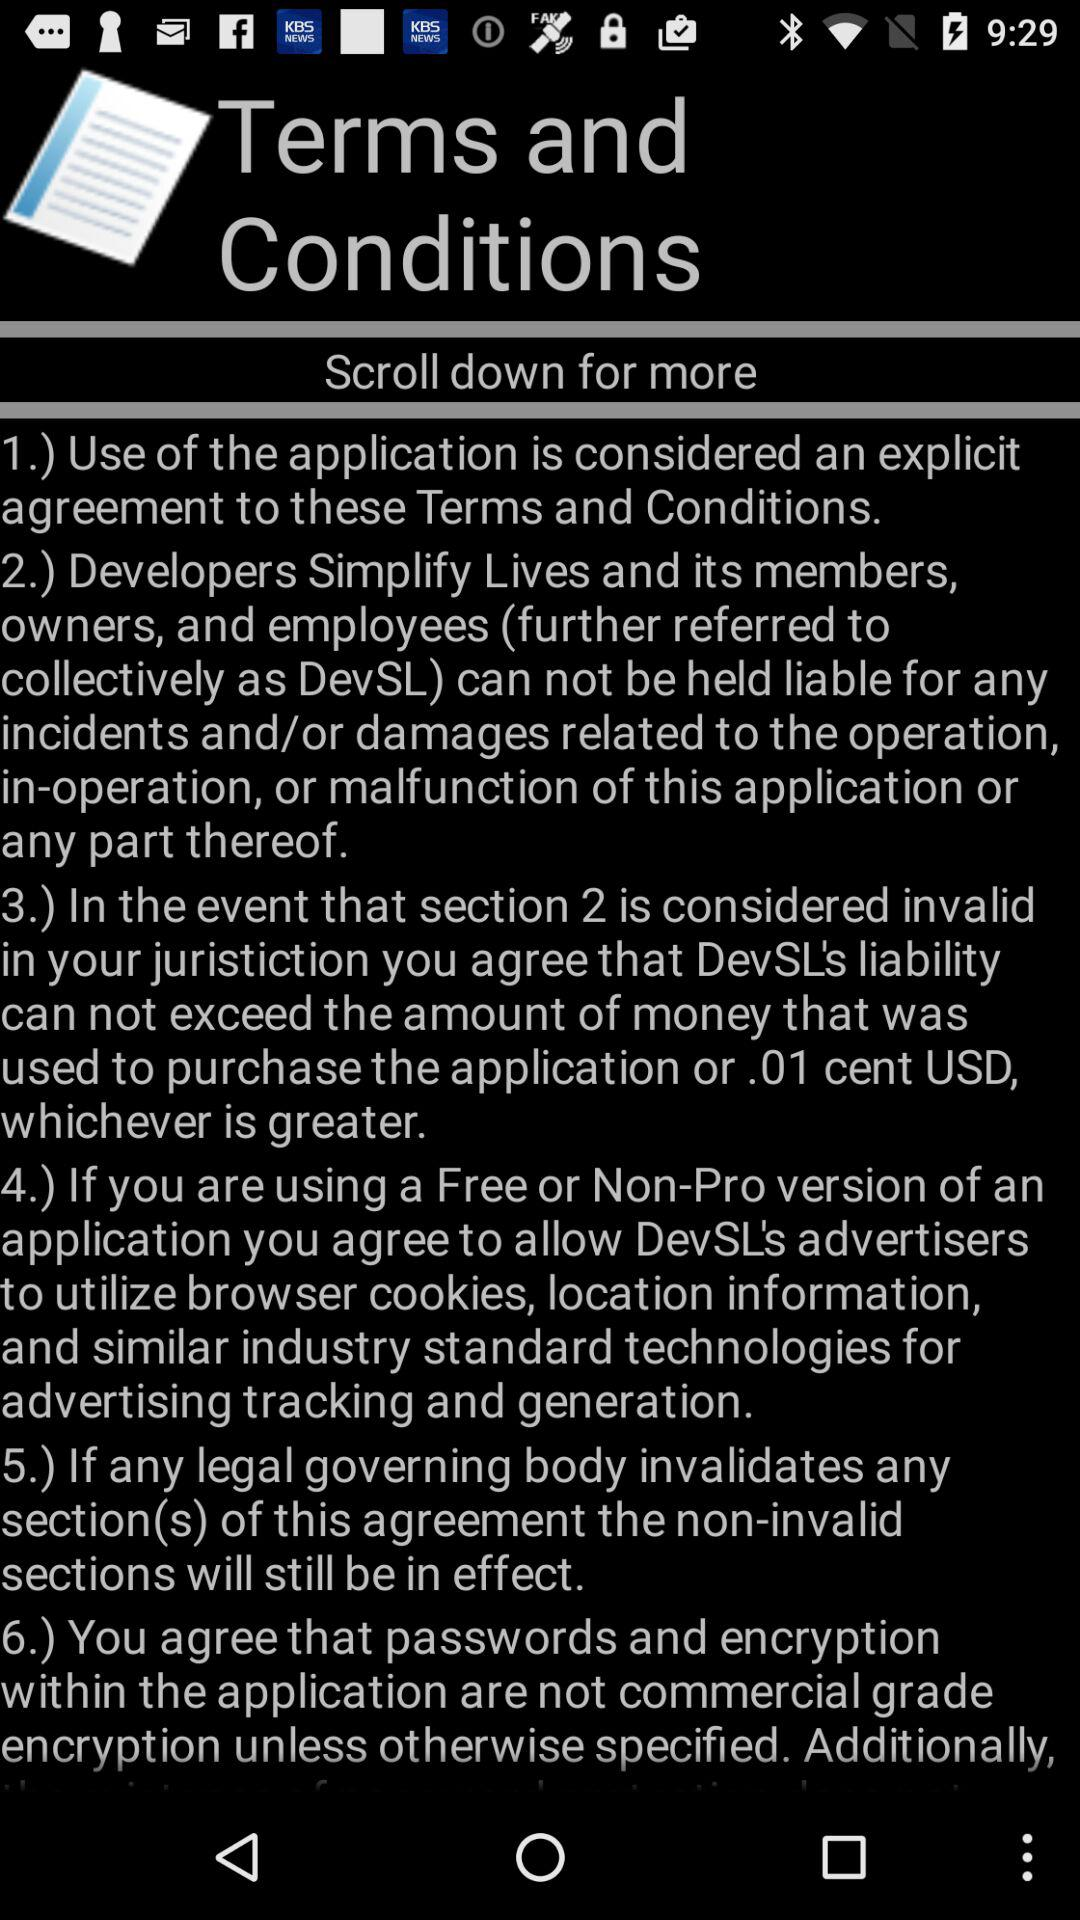How many sections are there in the terms and conditions?
Answer the question using a single word or phrase. 6 